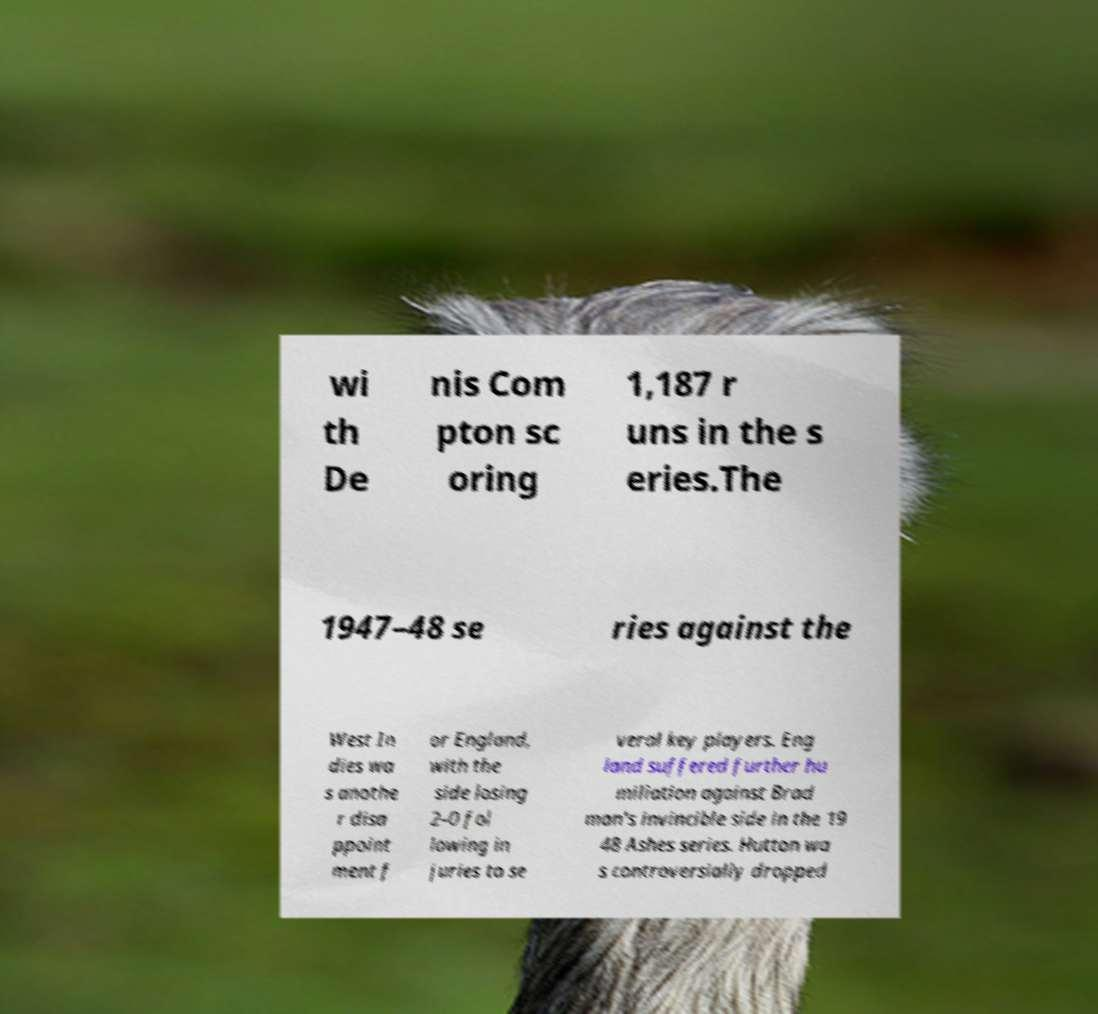Can you read and provide the text displayed in the image?This photo seems to have some interesting text. Can you extract and type it out for me? wi th De nis Com pton sc oring 1,187 r uns in the s eries.The 1947–48 se ries against the West In dies wa s anothe r disa ppoint ment f or England, with the side losing 2–0 fol lowing in juries to se veral key players. Eng land suffered further hu miliation against Brad man's invincible side in the 19 48 Ashes series. Hutton wa s controversially dropped 